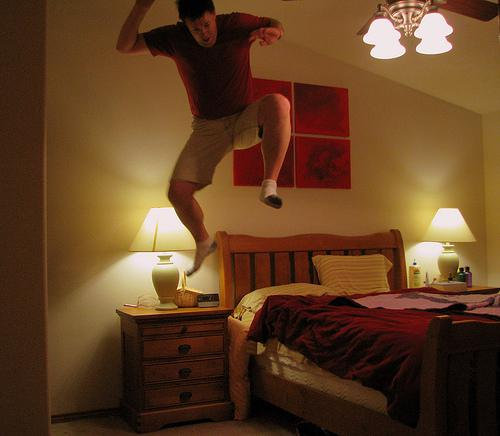Question: what is the color of his shirt?
Choices:
A. Red.
B. Blue.
C. Orange.
D. Green.
Answer with the letter. Answer: A Question: what is the man doing?
Choices:
A. Singing.
B. Jumping.
C. Surfing.
D. Skating.
Answer with the letter. Answer: B Question: why is he jumping?
Choices:
A. Competition.
B. Touch ceiling.
C. Playing.
D. Dunking a ball.
Answer with the letter. Answer: C Question: where is this place?
Choices:
A. Kitchen.
B. Hallway.
C. Bathroom.
D. Bedroom.
Answer with the letter. Answer: D Question: what is he holding?
Choices:
A. Nothing.
B. Racquet.
C. Bat.
D. Sword.
Answer with the letter. Answer: A 